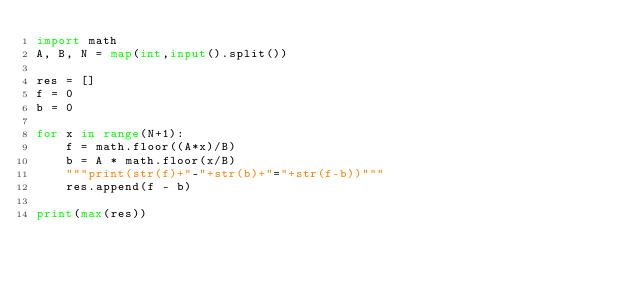Convert code to text. <code><loc_0><loc_0><loc_500><loc_500><_Python_>import math
A, B, N = map(int,input().split())

res = []
f = 0
b = 0

for x in range(N+1):
    f = math.floor((A*x)/B)
    b = A * math.floor(x/B)
    """print(str(f)+"-"+str(b)+"="+str(f-b))"""
    res.append(f - b)

print(max(res))
</code> 